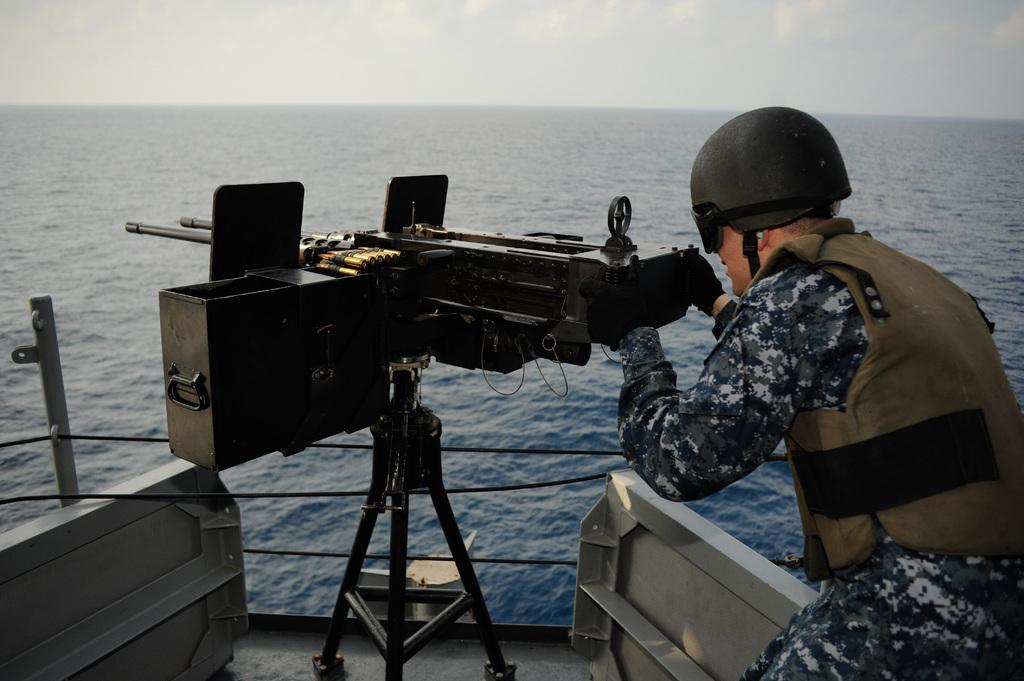Who or what is in the image? There is a person in the image. What is the person holding? The person is holding an object that looks like a gun. Where is the person located? The person is on a ship. What type of environment is the ship in? The ship is on the ocean. What additional objects can be seen in the image? There are ropes and poles in the image. What can be seen in the sky? The sky is visible in the image. Can you see any squirrels eating berries in the image? No, there are no squirrels or berries present in the image. Is there a hen visible on the ship in the image? No, there is no hen visible in the image. 